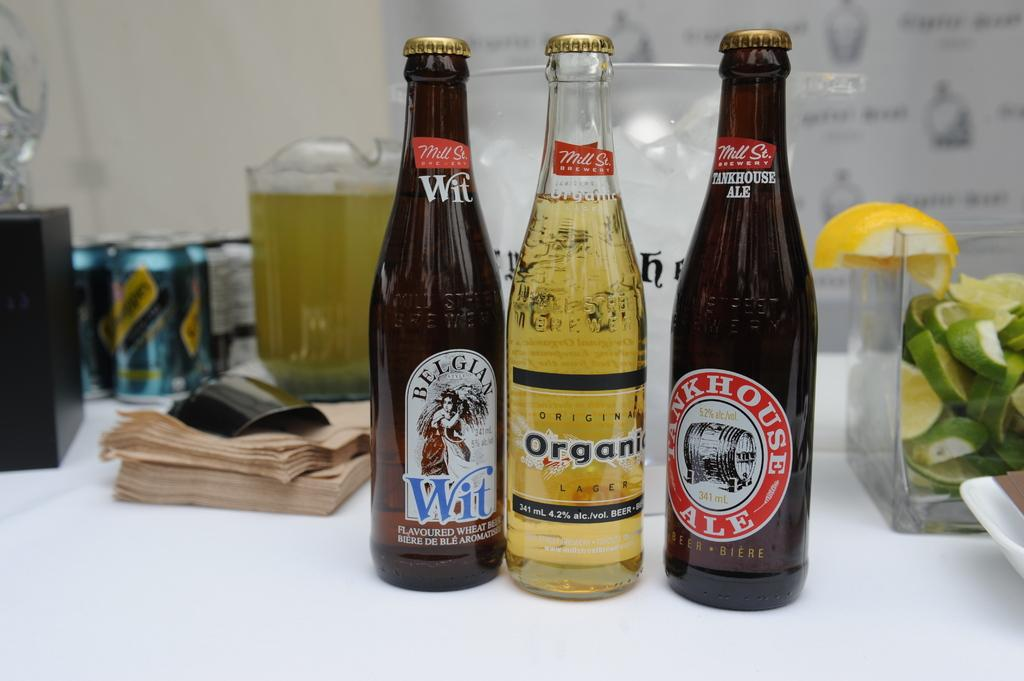<image>
Render a clear and concise summary of the photo. 3 bottles of different ale beers on a table with schweppes soda and a pitcher. 